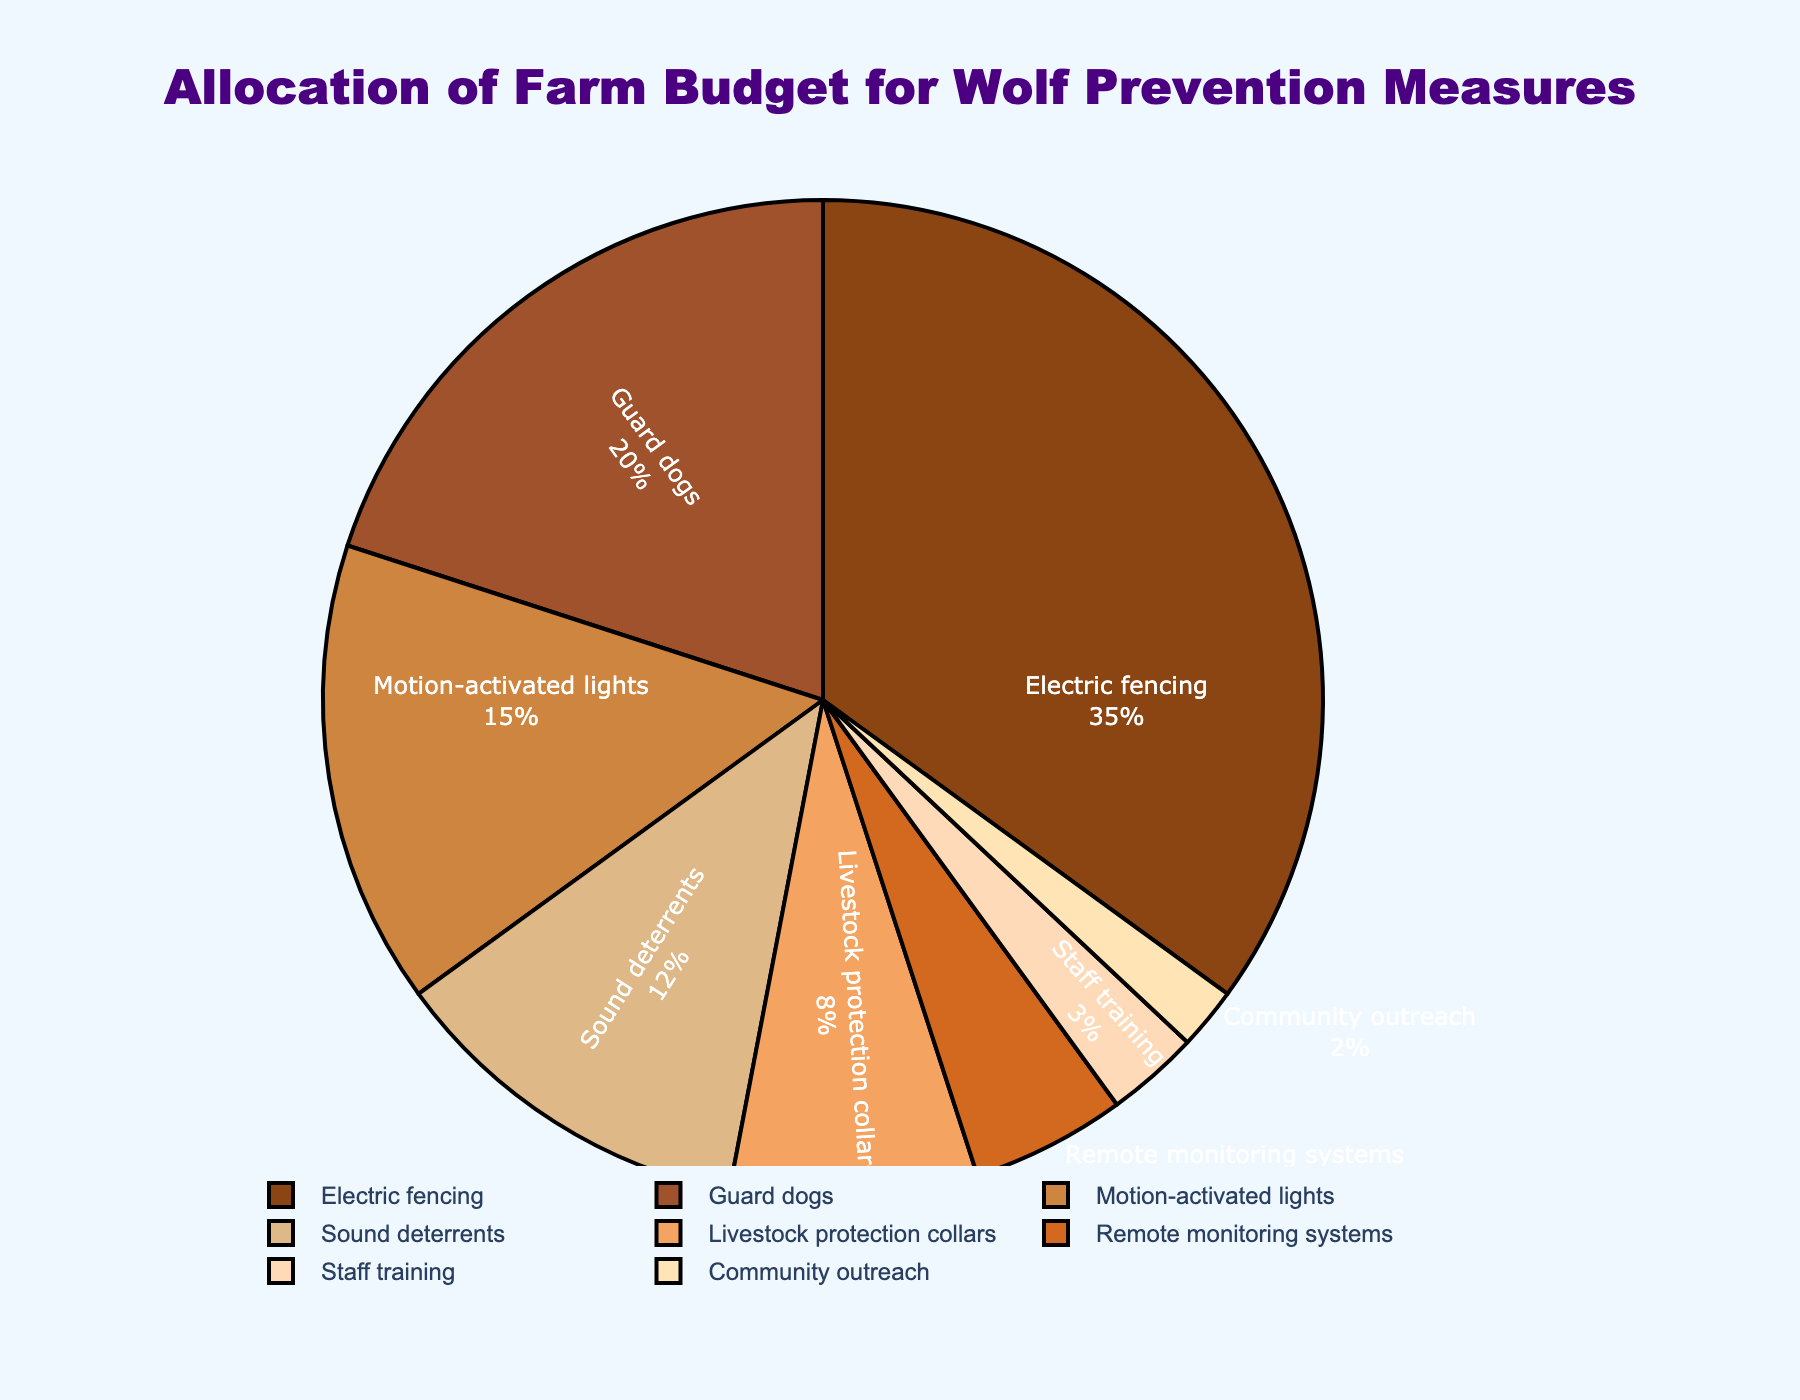Which category has the highest allocation in the farm budget for wolf prevention measures? Check the category with the largest percentage in the pie chart, which is the one occupying the most space and labeled with the highest value.
Answer: Electric fencing Which category has the lowest allocation in the farm budget for wolf prevention measures? Identify the category with the smallest percentage in the pie chart, usually occupying the least space and marked with the lowest value.
Answer: Community outreach What's the combined percentage allocation for Guard dogs and Motion-activated lights? Add the percentages of Guard dogs and Motion-activated lights: 20% + 15% = 35%
Answer: 35% Is the allocation for Remote monitoring systems higher than Staff training? Compare the percentages of Remote monitoring systems (5%) and Staff training (3%) in the pie chart and see which one is higher.
Answer: Yes Which category, Electric fencing or Sound deterrents, has a greater allocation, and by how much? Compare the percentages of Electric fencing (35%) and Sound deterrents (12%), then calculate the difference: 35% - 12% = 23%
Answer: Electric fencing, by 23% What's the total percentage allocation for categories below 10%? Add the percentages of categories below 10%: Livestock protection collars (8%), Remote monitoring systems (5%), Staff training (3%), and Community outreach (2%): 8% + 5% + 3% + 2% = 18%
Answer: 18% How does the allocation for Motion-activated lights compare to that for Sound deterrents? Compare the percentages between Motion-activated lights (15%) and Sound deterrents (12%) to see which one is larger and by how much: 15% - 12% = 3%
Answer: Motion-activated lights is higher by 3% If budgeting for Electric fencing and Guard dogs was combined, what would the new percentage allocation be? Add the percentages of Electric fencing (35%) and Guard dogs (20%): 35% + 20% = 55%
Answer: 55% Which color represents Livestock protection collars? Identify the color used in the section of the pie chart labeled "Livestock protection collars". The color matches the provided palette and visually corresponds to the section.
Answer: Light orange 